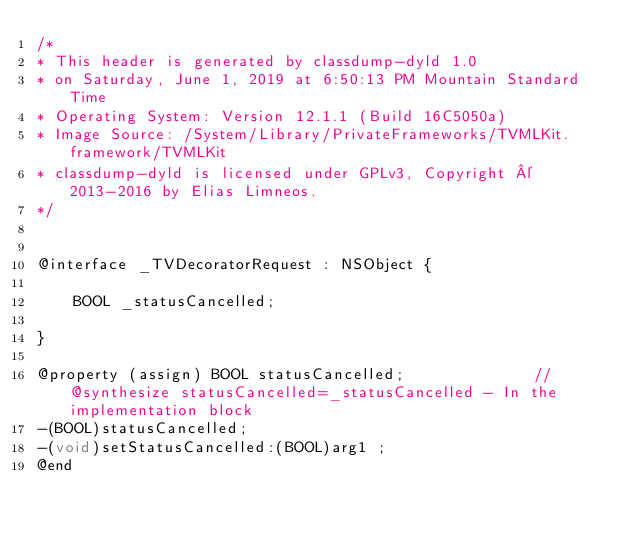Convert code to text. <code><loc_0><loc_0><loc_500><loc_500><_C_>/*
* This header is generated by classdump-dyld 1.0
* on Saturday, June 1, 2019 at 6:50:13 PM Mountain Standard Time
* Operating System: Version 12.1.1 (Build 16C5050a)
* Image Source: /System/Library/PrivateFrameworks/TVMLKit.framework/TVMLKit
* classdump-dyld is licensed under GPLv3, Copyright © 2013-2016 by Elias Limneos.
*/


@interface _TVDecoratorRequest : NSObject {

	BOOL _statusCancelled;

}

@property (assign) BOOL statusCancelled;              //@synthesize statusCancelled=_statusCancelled - In the implementation block
-(BOOL)statusCancelled;
-(void)setStatusCancelled:(BOOL)arg1 ;
@end

</code> 